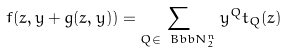Convert formula to latex. <formula><loc_0><loc_0><loc_500><loc_500>f ( z , y + g ( z , y ) ) = \sum _ { Q \in \ B b b N _ { 2 } ^ { n } } y ^ { Q } t _ { Q } ( z )</formula> 